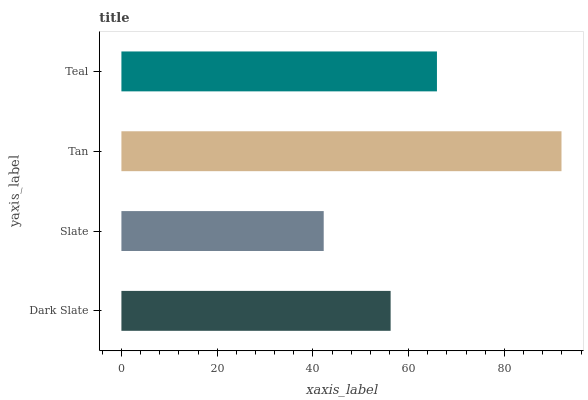Is Slate the minimum?
Answer yes or no. Yes. Is Tan the maximum?
Answer yes or no. Yes. Is Tan the minimum?
Answer yes or no. No. Is Slate the maximum?
Answer yes or no. No. Is Tan greater than Slate?
Answer yes or no. Yes. Is Slate less than Tan?
Answer yes or no. Yes. Is Slate greater than Tan?
Answer yes or no. No. Is Tan less than Slate?
Answer yes or no. No. Is Teal the high median?
Answer yes or no. Yes. Is Dark Slate the low median?
Answer yes or no. Yes. Is Dark Slate the high median?
Answer yes or no. No. Is Teal the low median?
Answer yes or no. No. 